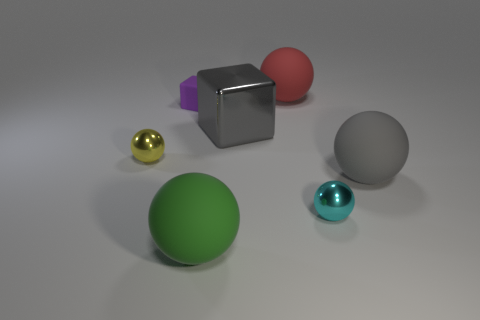Subtract 1 spheres. How many spheres are left? 4 Add 3 big cyan cylinders. How many objects exist? 10 Subtract all green balls. How many balls are left? 4 Subtract all large red balls. How many balls are left? 4 Subtract all blue balls. Subtract all gray cylinders. How many balls are left? 5 Subtract all blocks. How many objects are left? 5 Subtract all rubber things. Subtract all blue things. How many objects are left? 3 Add 7 cyan objects. How many cyan objects are left? 8 Add 5 big green things. How many big green things exist? 6 Subtract 0 brown cylinders. How many objects are left? 7 